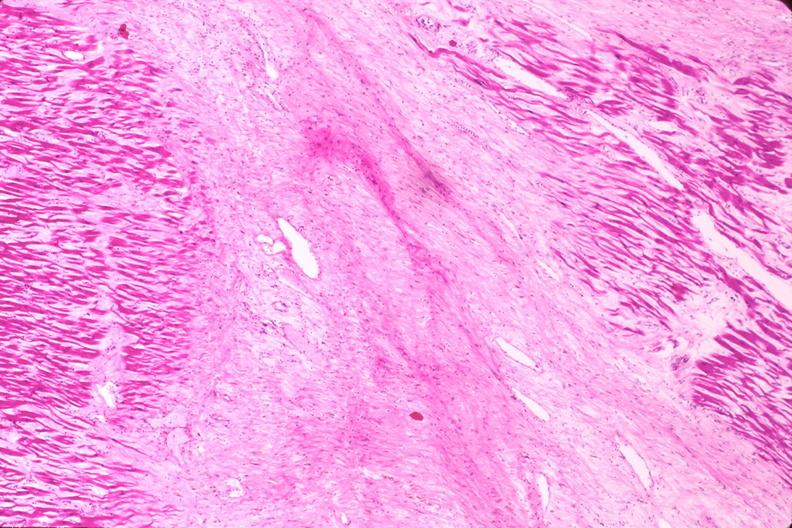s very good example present?
Answer the question using a single word or phrase. No 